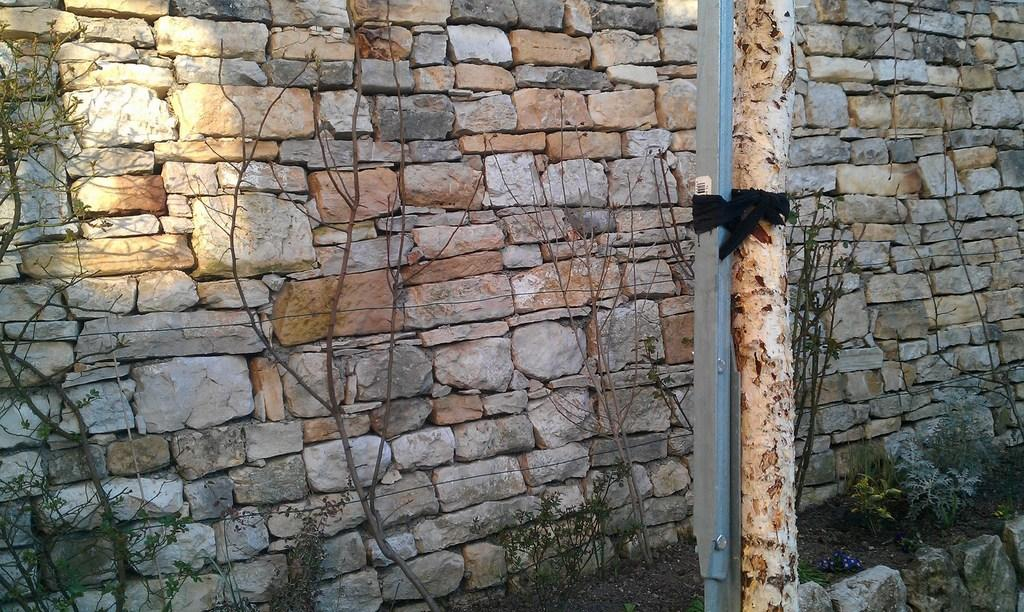What type of wall is visible in the image? There is a wall built with stones in the image. What other elements can be seen in the image? There are plants, red stems, and the bark of a tree in the image. Can you describe the plants in the image? The plants have red stems. How is the bark of the tree attached to the pole? The bark of the tree is tied to a pole with a ribbon. How does the zephyr affect the plants in the image? There is no mention of a zephyr or wind in the image, so we cannot determine its effect on the plants. 